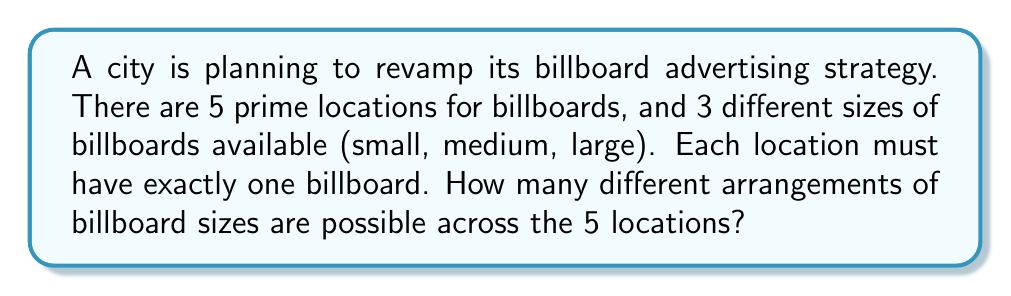Help me with this question. Let's approach this step-by-step:

1) We have 5 locations, and for each location, we need to choose one of 3 possible sizes.

2) This scenario is a perfect example of the multiplication principle in combinatorics.

3) For the first location, we have 3 choices.

4) For the second location, we again have 3 choices, regardless of what we chose for the first location.

5) This pattern continues for all 5 locations.

6) Therefore, the total number of possible arrangements is:

   $$3 \times 3 \times 3 \times 3 \times 3 = 3^5$$

7) We can calculate this:
   
   $$3^5 = 3 \times 3 \times 3 \times 3 \times 3 = 243$$

Thus, there are 243 different possible arrangements of billboard sizes across the 5 locations.
Answer: $3^5 = 243$ 